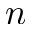<formula> <loc_0><loc_0><loc_500><loc_500>n</formula> 